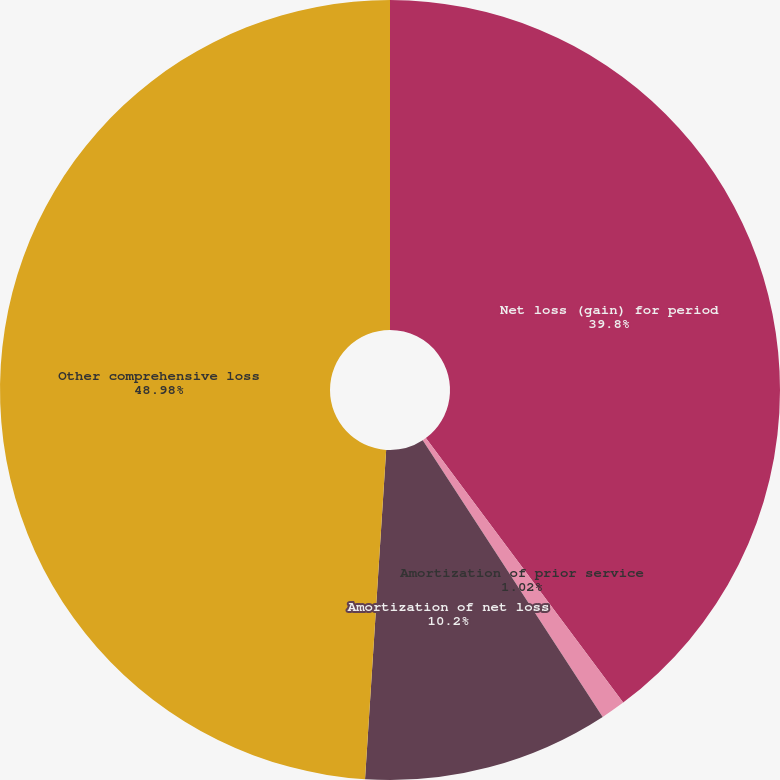Convert chart to OTSL. <chart><loc_0><loc_0><loc_500><loc_500><pie_chart><fcel>Net loss (gain) for period<fcel>Amortization of prior service<fcel>Amortization of net loss<fcel>Other comprehensive loss<nl><fcel>39.8%<fcel>1.02%<fcel>10.2%<fcel>48.98%<nl></chart> 